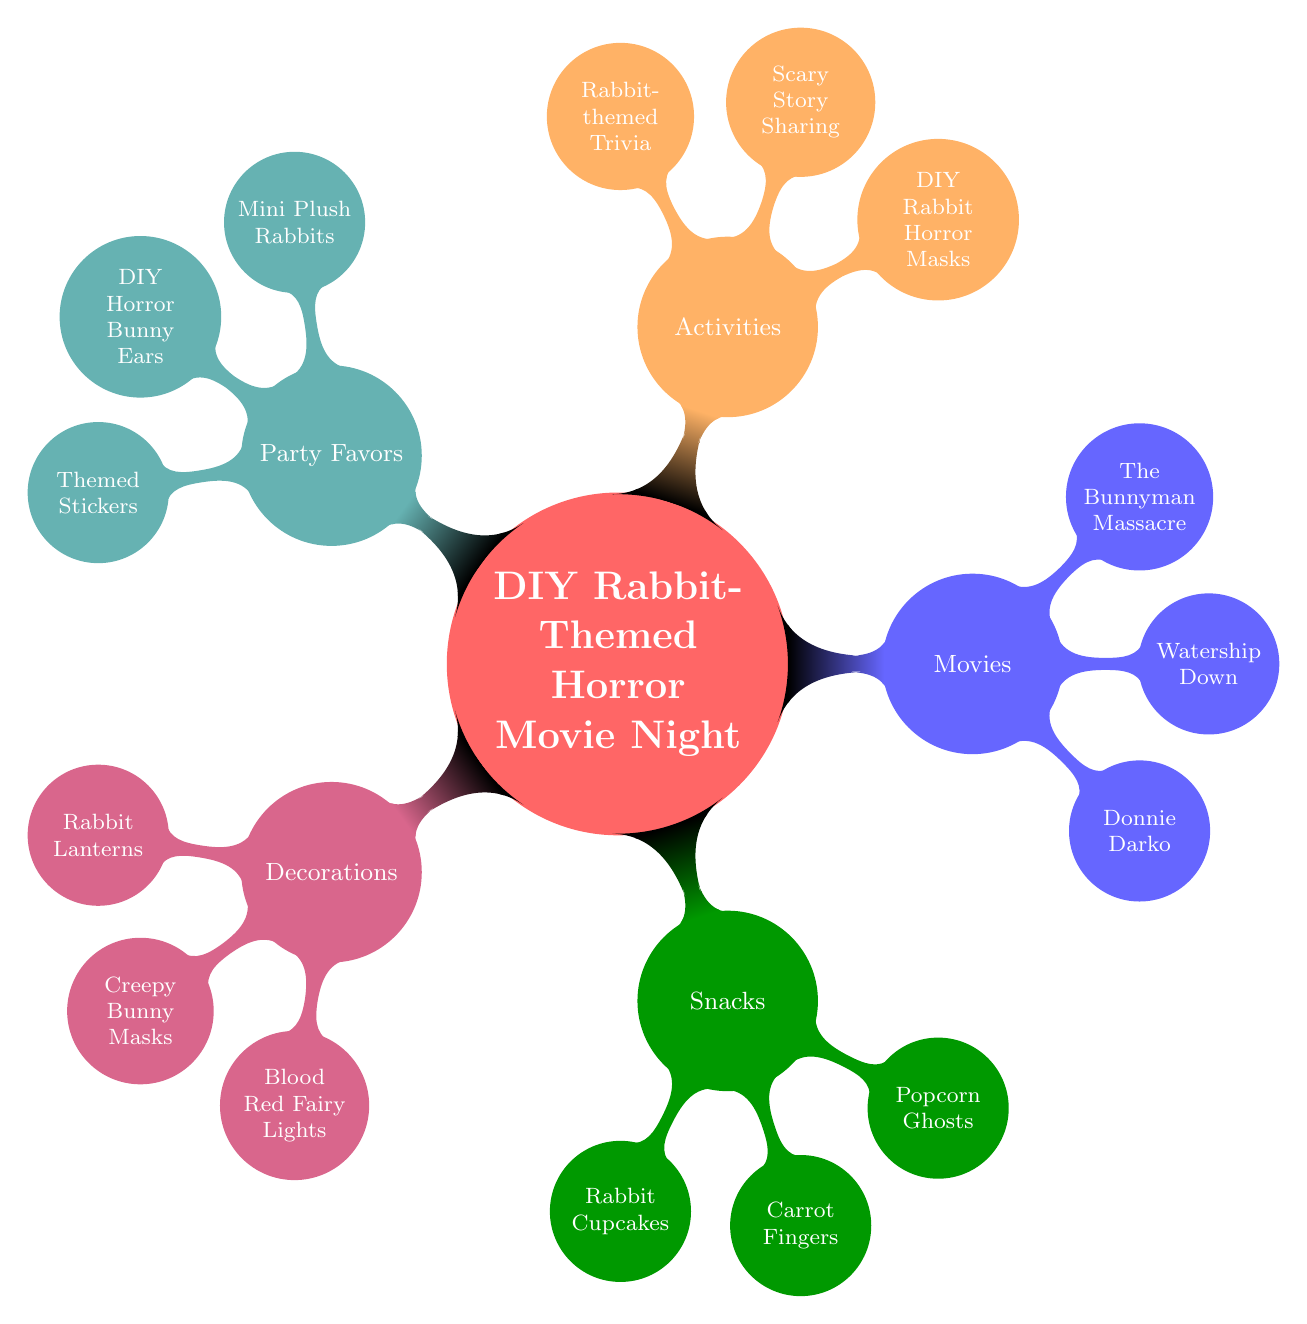What is the main theme of the mind map? The title node at the center of the diagram explicitly states the theme as "DIY Rabbit-Themed Horror Movie Night". This is the subject around which all other nodes and sub-nodes are organized.
Answer: DIY Rabbit-Themed Horror Movie Night How many main categories are in the diagram? Counting the main child nodes branching from the central theme, there are five major categories: Decorations, Snacks, Movies, Activities, and Party Favors.
Answer: 5 What snack features baby carrots? In the Snacks category, the specific snack listed that includes baby carrots is "Carrot Fingers". This can be found under the Snacks nodes.
Answer: Carrot Fingers Which movie features a killer in a bunny suit? The movie listed under the Movies category that features a killer in a bunny suit is "The Bunnyman Massacre", as it is mentioned as the horror movie that fits this description.
Answer: The Bunnyman Massacre What activity involves sharing ghost stories? The Activities node identifies "Scary Story Sharing" as the activity where participants share spooky rabbit-themed ghost stories. This clearly indicates its connection to ghost stories.
Answer: Scary Story Sharing Which color is associated with the Party Favors category in the mind map? Each main category in the mind map is assigned a distinct color. The Party Favors category is colored teal, as indicated in the diagram.
Answer: Teal How many types of decorations are listed in the diagram? Under the Decorations node, there are three specific decorations mentioned: Rabbit Lanterns, Creepy Bunny Masks, and Blood Red Fairy Lights. Counting these gives a total of three types.
Answer: 3 What is included in the Party Favors that are cute but spooky? Within the Party Favors section, the item that is described as both cute and spooky is "Mini Plush Rabbits", which indicates their adorable yet eerie character.
Answer: Mini Plush Rabbits What activity involves creating something with craft supplies? The activity associated with making something using craft supplies is "DIY Rabbit Horror Masks". This is listed under the Activities node where crafting is detailed.
Answer: DIY Rabbit Horror Masks 